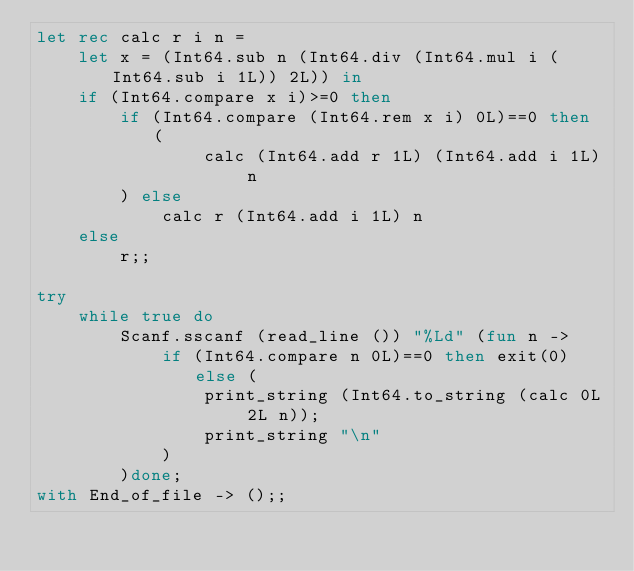<code> <loc_0><loc_0><loc_500><loc_500><_OCaml_>let rec calc r i n =
	let x = (Int64.sub n (Int64.div (Int64.mul i (Int64.sub i 1L)) 2L)) in
	if (Int64.compare x i)>=0 then
		if (Int64.compare (Int64.rem x i) 0L)==0 then (
				calc (Int64.add r 1L) (Int64.add i 1L) n
		) else
			calc r (Int64.add i 1L) n
	else
		r;;

try
	while true do
		Scanf.sscanf (read_line ()) "%Ld" (fun n ->
			if (Int64.compare n 0L)==0 then exit(0) else (
				print_string (Int64.to_string (calc 0L 2L n));
				print_string "\n"
			)
		)done;
with End_of_file -> ();;</code> 